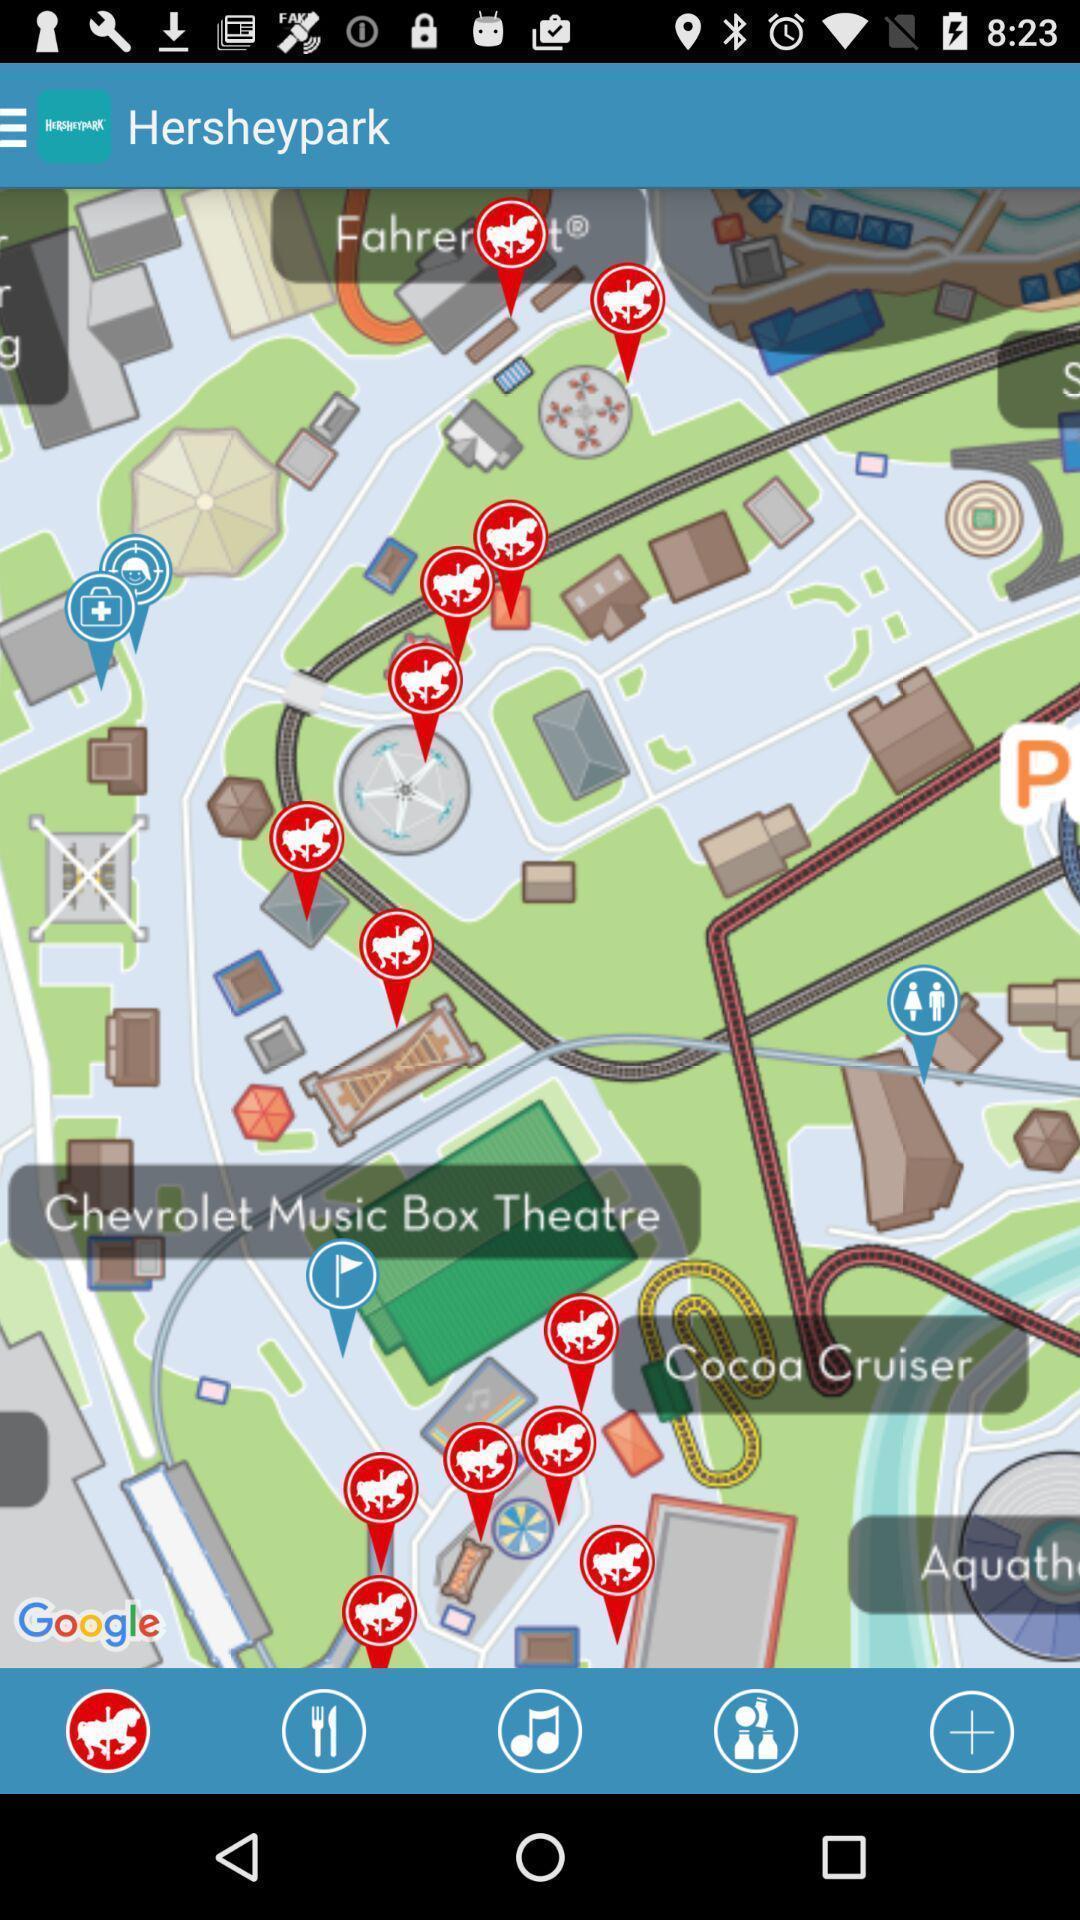What details can you identify in this image? Page displaying the location points of different places. 